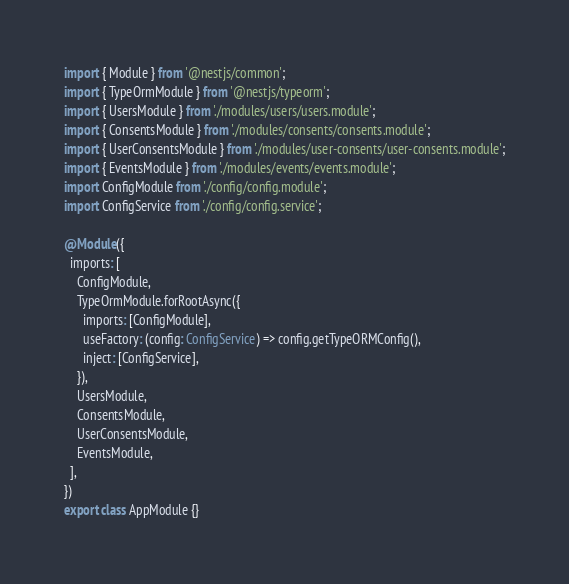<code> <loc_0><loc_0><loc_500><loc_500><_TypeScript_>import { Module } from '@nestjs/common';
import { TypeOrmModule } from '@nestjs/typeorm';
import { UsersModule } from './modules/users/users.module';
import { ConsentsModule } from './modules/consents/consents.module';
import { UserConsentsModule } from './modules/user-consents/user-consents.module';
import { EventsModule } from './modules/events/events.module';
import ConfigModule from './config/config.module';
import ConfigService from './config/config.service';

@Module({
  imports: [
    ConfigModule,
    TypeOrmModule.forRootAsync({
      imports: [ConfigModule],
      useFactory: (config: ConfigService) => config.getTypeORMConfig(),
      inject: [ConfigService],
    }),
    UsersModule,
    ConsentsModule,
    UserConsentsModule,
    EventsModule,
  ],
})
export class AppModule {}
</code> 